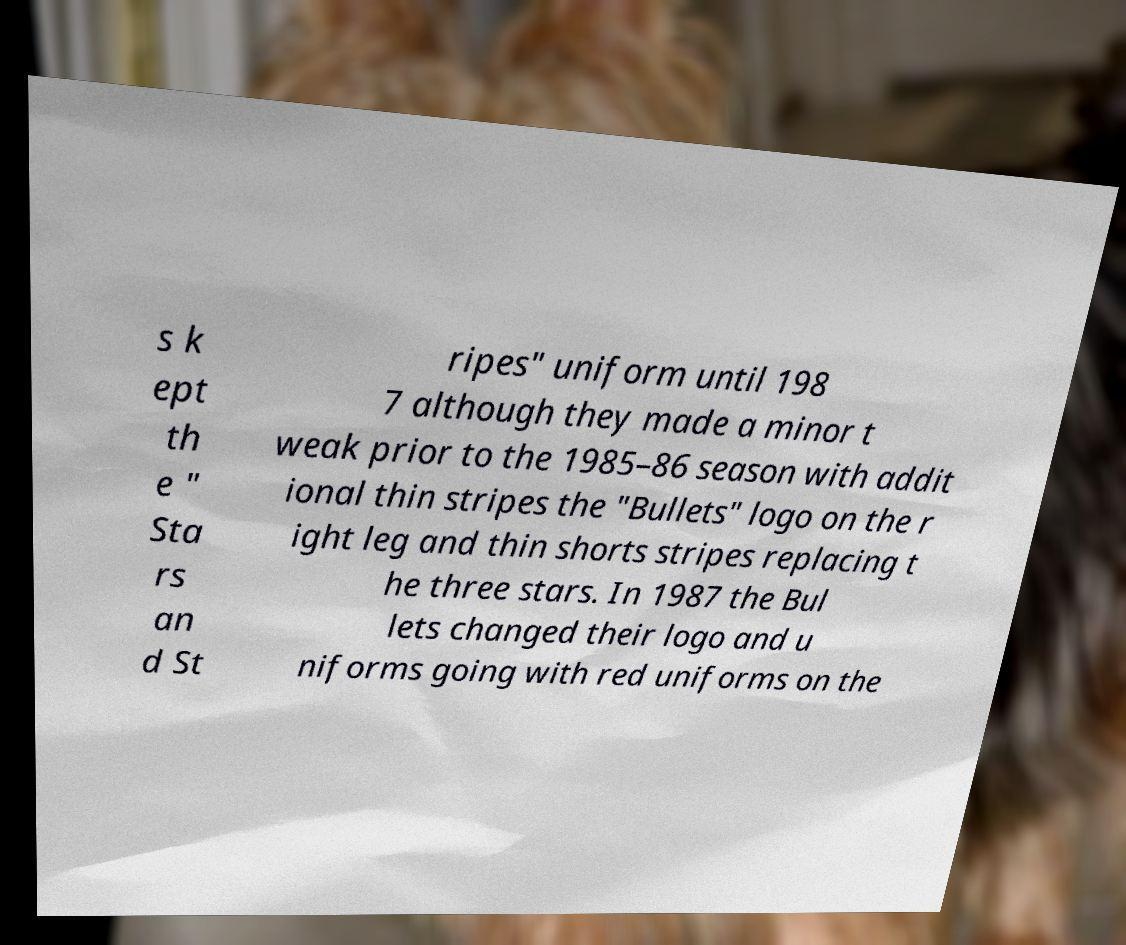Can you accurately transcribe the text from the provided image for me? s k ept th e " Sta rs an d St ripes" uniform until 198 7 although they made a minor t weak prior to the 1985–86 season with addit ional thin stripes the "Bullets" logo on the r ight leg and thin shorts stripes replacing t he three stars. In 1987 the Bul lets changed their logo and u niforms going with red uniforms on the 